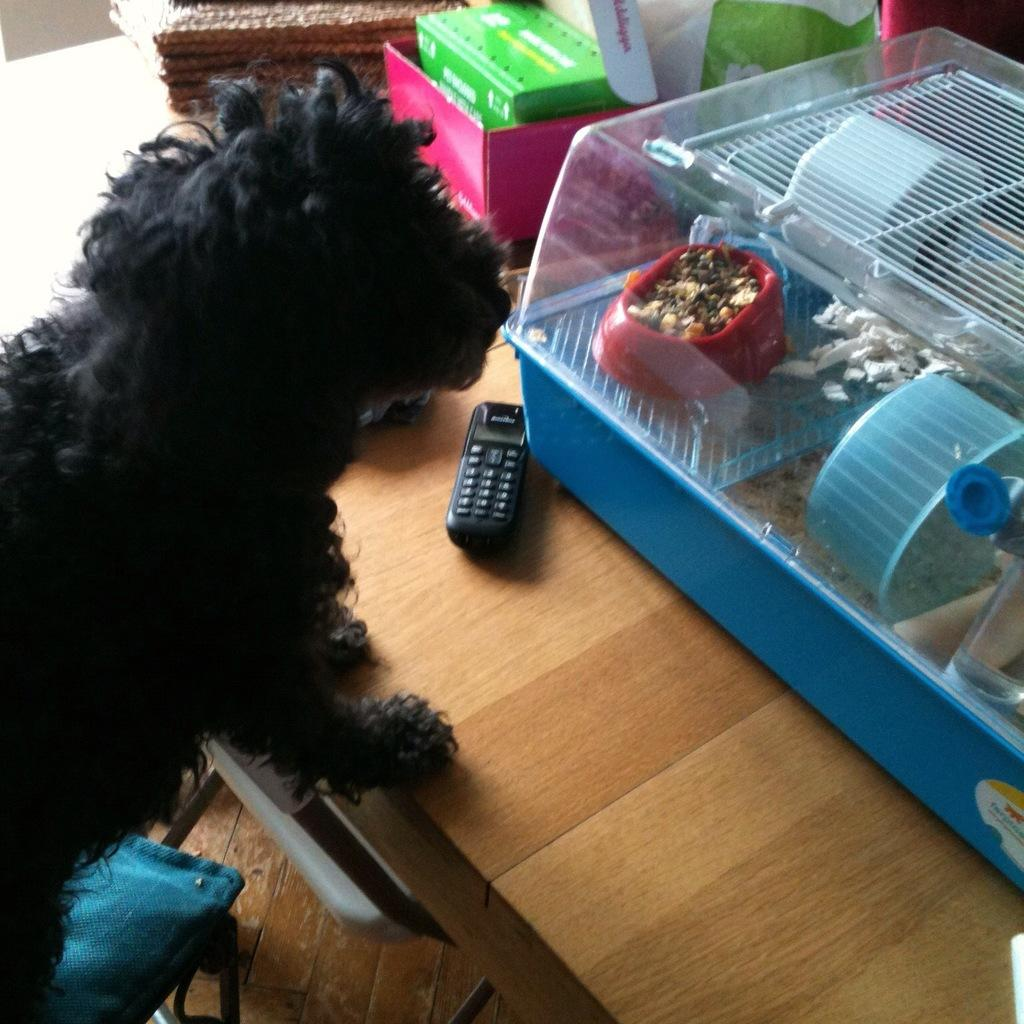What animal is on the left side of the picture? There is a dog on the left side of the picture. What piece of furniture is also on the left side of the picture? There is a chair on the left side of the picture. What piece of furniture is on the right side of the picture? There is a table on the right side of the picture. What is hanging from the table? There is a mobile on the table. What objects are on the table besides the mobile? There are boxes, clothes, covers, and a dog house on the table. How does the dog's partner interact with the dust on the table? There is no mention of a partner for the dog in the image, and there is no dust visible on the table. What type of crack is present in the dog house on the table? There is no crack present in the dog house on the table, as it is not mentioned in the provided facts. 